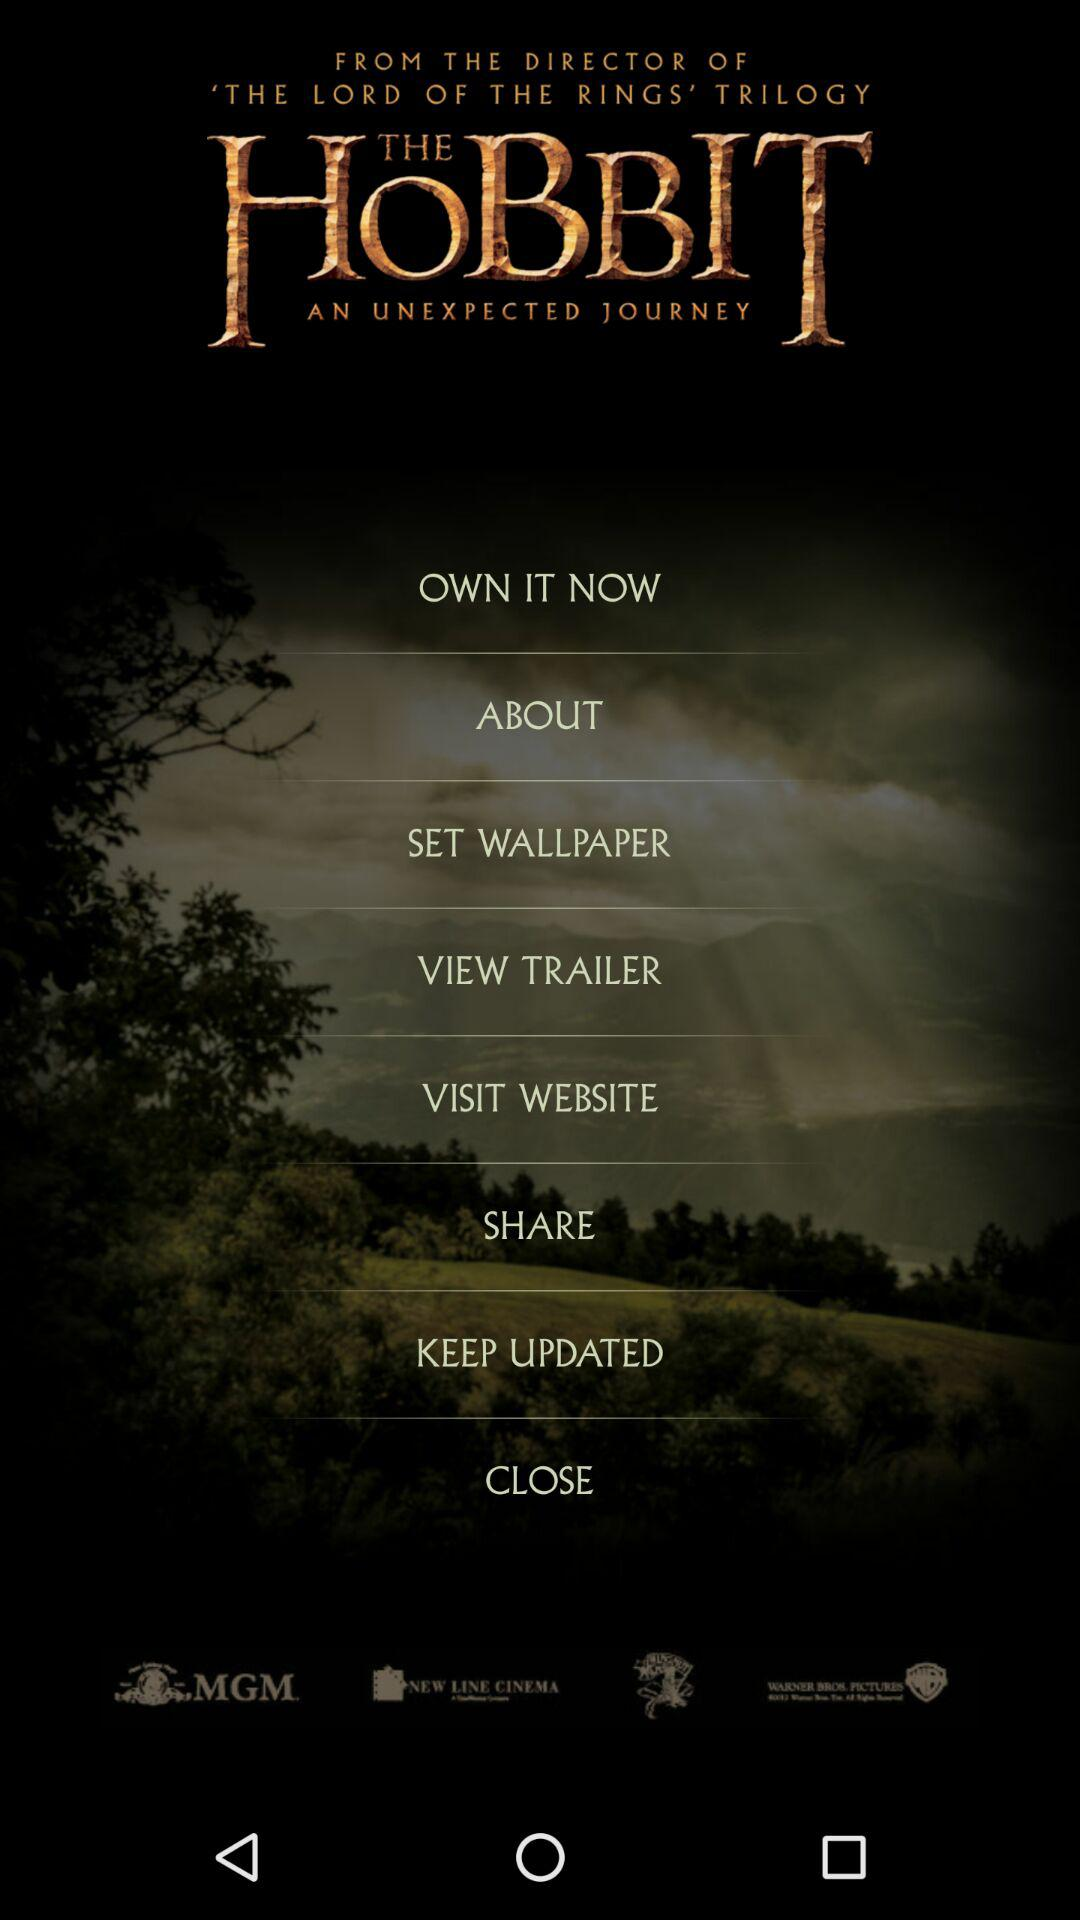What's the title of the movie? The title of the movie is "THE HOBBIT AN UNEXPECTED JOURNEY". 